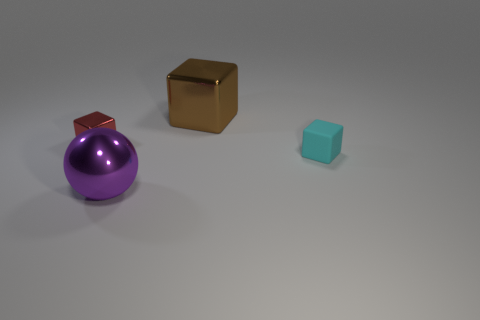What size is the purple shiny ball?
Your answer should be very brief. Large. What color is the other small object that is the same shape as the rubber thing?
Your answer should be compact. Red. Is there any other thing of the same color as the small shiny block?
Your response must be concise. No. There is a shiny block that is right of the large ball; does it have the same size as the metallic thing that is in front of the cyan object?
Offer a terse response. Yes. Is the number of shiny spheres that are in front of the cyan object the same as the number of large metal objects that are on the right side of the brown metal thing?
Provide a short and direct response. No. Does the brown object have the same size as the block that is right of the big metal block?
Offer a terse response. No. Are there any purple balls to the right of the tiny cube behind the cyan object?
Your response must be concise. Yes. Are there any purple things that have the same shape as the tiny red metallic object?
Keep it short and to the point. No. How many purple balls are on the left side of the block on the left side of the large shiny thing behind the purple object?
Offer a very short reply. 0. Do the tiny metal block and the small thing right of the brown metallic cube have the same color?
Keep it short and to the point. No. 